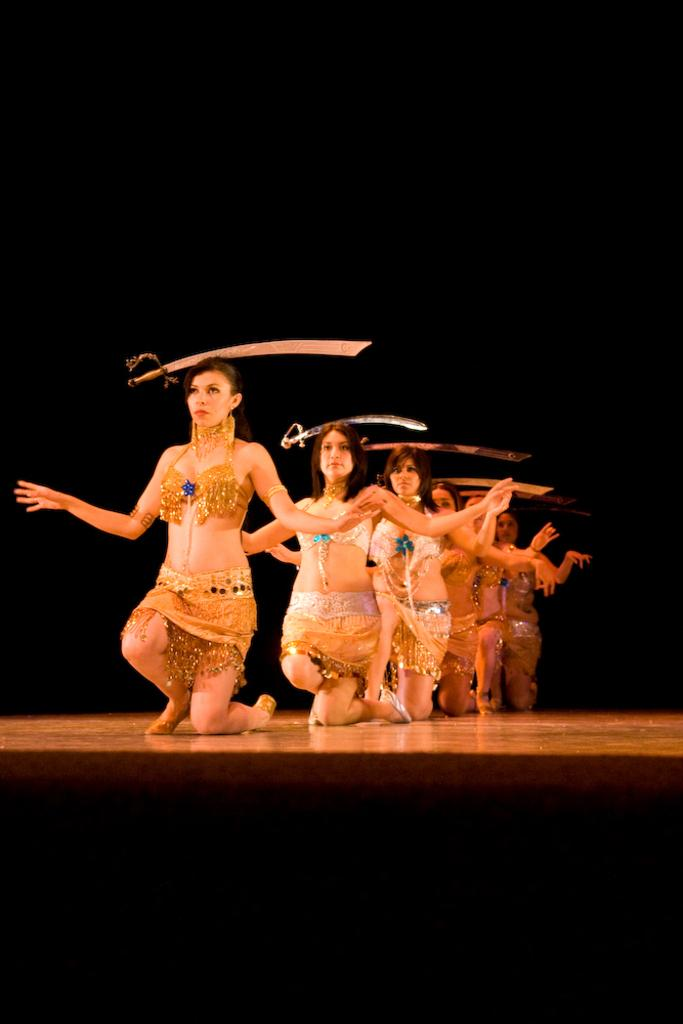What are the people on the stage doing? The people on the stage are sitting on their knees. What can be seen on the heads of the people on the stage? The people on the stage have swords on their heads. What is the color of the background in the image? The background of the image is dark. What type of decision can be seen hanging from the ceiling in the image? There is no decision hanging from the ceiling in the image; it features people sitting on their knees with swords on their heads. Can you tell me how many icicles are visible in the image? There are no icicles present in the image. 